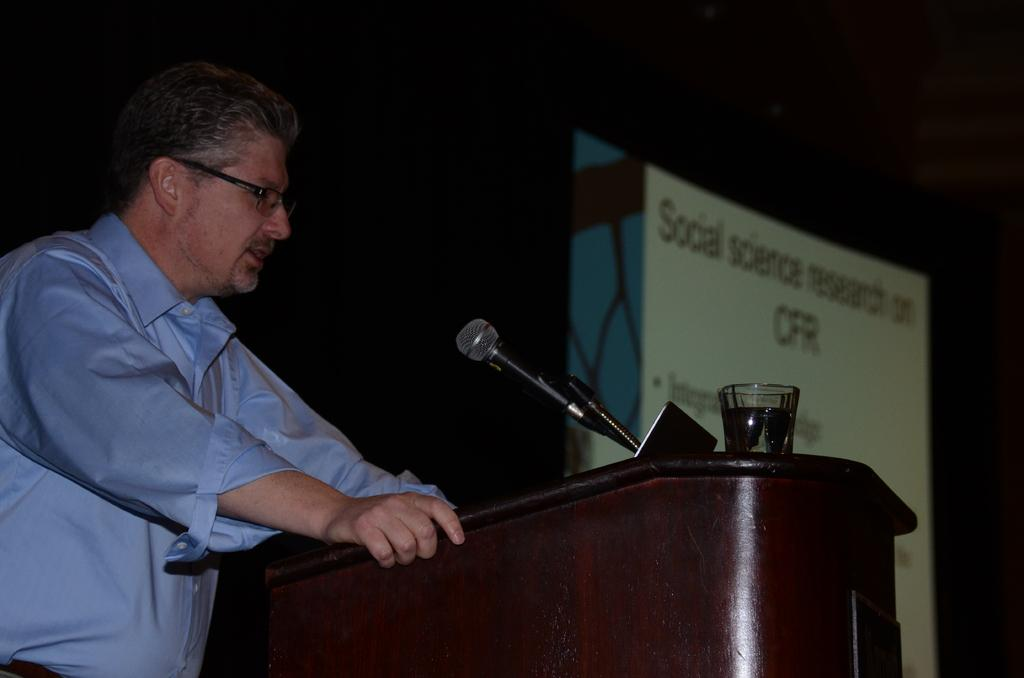What is the main subject of the image? The main subject of the image is a man. What can be observed about the man's appearance? The man is wearing spectacles. What is the man doing in the image? The man is standing at a podium and talking on a microphone. What object is present on the podium? There is a glass on the podium. What is visible beside the man? There is a banner beside the man. What type of jewel is the man wearing on his finger in the image? There is no jewel visible on the man's finger in the image. How long has the man been a beginner at public speaking? The image does not provide information about the man's experience with public speaking, so it cannot be determined from the image. 